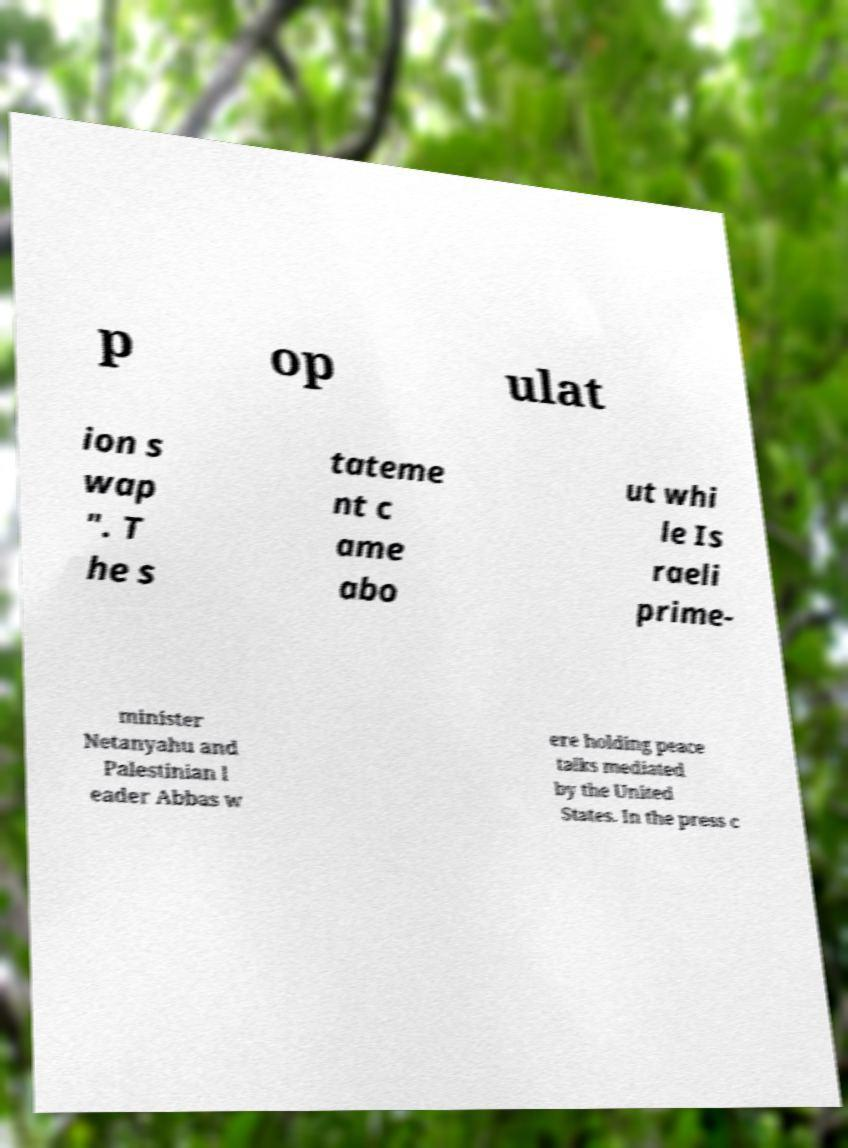I need the written content from this picture converted into text. Can you do that? p op ulat ion s wap ″. T he s tateme nt c ame abo ut whi le Is raeli prime- minister Netanyahu and Palestinian l eader Abbas w ere holding peace talks mediated by the United States. In the press c 